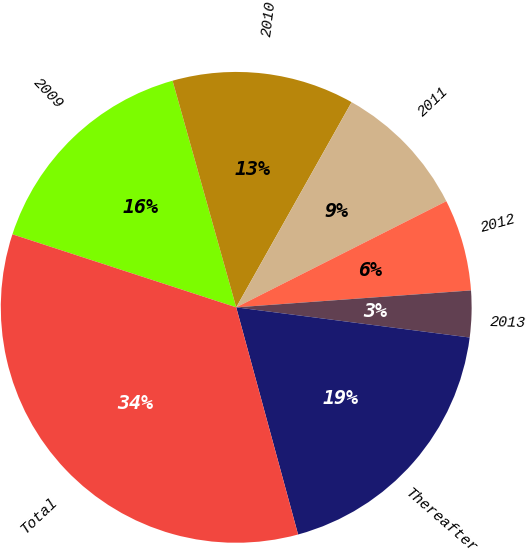Convert chart. <chart><loc_0><loc_0><loc_500><loc_500><pie_chart><fcel>2009<fcel>2010<fcel>2011<fcel>2012<fcel>2013<fcel>Thereafter<fcel>Total<nl><fcel>15.62%<fcel>12.51%<fcel>9.4%<fcel>6.3%<fcel>3.19%<fcel>18.72%<fcel>34.25%<nl></chart> 